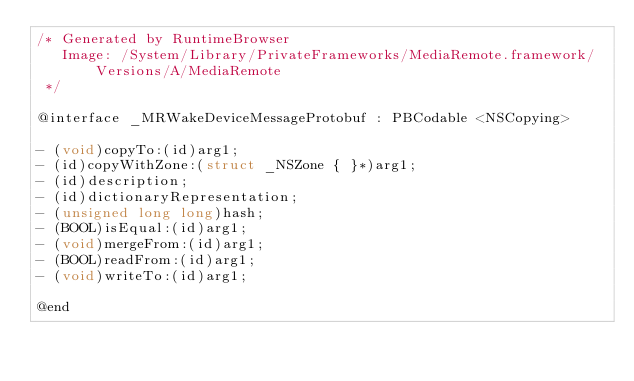Convert code to text. <code><loc_0><loc_0><loc_500><loc_500><_C_>/* Generated by RuntimeBrowser
   Image: /System/Library/PrivateFrameworks/MediaRemote.framework/Versions/A/MediaRemote
 */

@interface _MRWakeDeviceMessageProtobuf : PBCodable <NSCopying>

- (void)copyTo:(id)arg1;
- (id)copyWithZone:(struct _NSZone { }*)arg1;
- (id)description;
- (id)dictionaryRepresentation;
- (unsigned long long)hash;
- (BOOL)isEqual:(id)arg1;
- (void)mergeFrom:(id)arg1;
- (BOOL)readFrom:(id)arg1;
- (void)writeTo:(id)arg1;

@end
</code> 